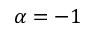Convert formula to latex. <formula><loc_0><loc_0><loc_500><loc_500>\alpha = - 1</formula> 